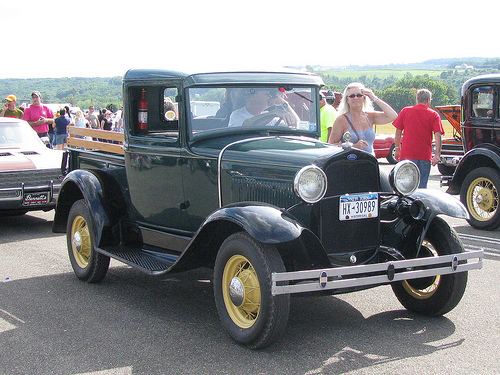<image>
Can you confirm if the woman is to the left of the car? No. The woman is not to the left of the car. From this viewpoint, they have a different horizontal relationship. 